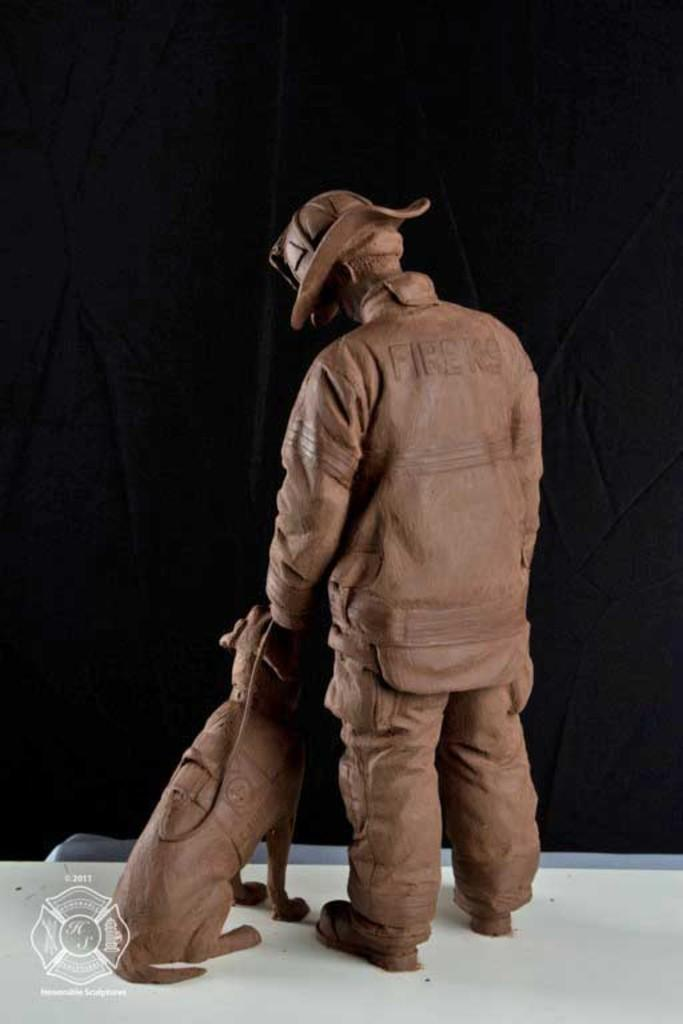What is depicted in the statue in the image? The statue is of a person and an animal. What is the statue wearing? The statue is wearing a dress and a hat. What color is the surface the statue is standing on? The surface is white. What color is the background of the image? The background of the image is black. How much debt does the person in the statue owe to the animal in the image? There is no indication of debt or any financial relationship between the person and the animal in the image. 